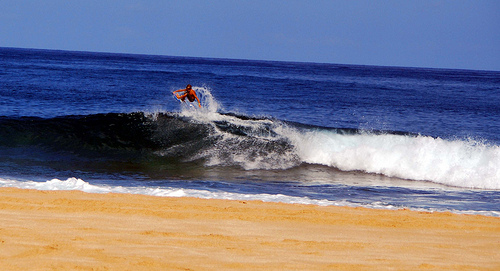What time of day does the lighting suggest and what effect does it have on the scene? The lighting in the image suggests it is midday, where the sun is at its zenith, casting vivid hues and contrasts that delineate the surfer's silhouette sharply against the water, while the wave’s textured surface glistens, adding a vibrant energy to the scene. 